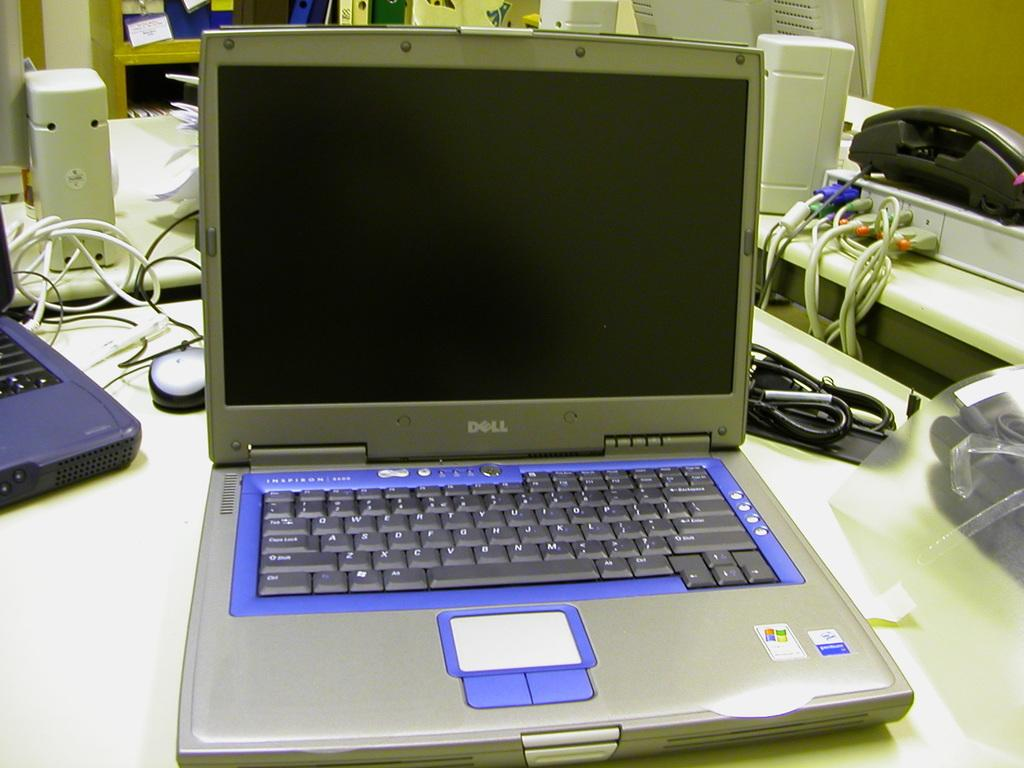What piece of furniture is present in the image? There is a table in the image. What electronic devices are on the table? There are laptops on the table. What else can be seen on the table besides laptops? There are wires and a telephone on the table, as well as other unspecified items. What type of picture is hanging on the wall behind the table in the image? There is no wall or picture visible in the image; it only shows a table with laptops, wires, a telephone, and other unspecified items. 